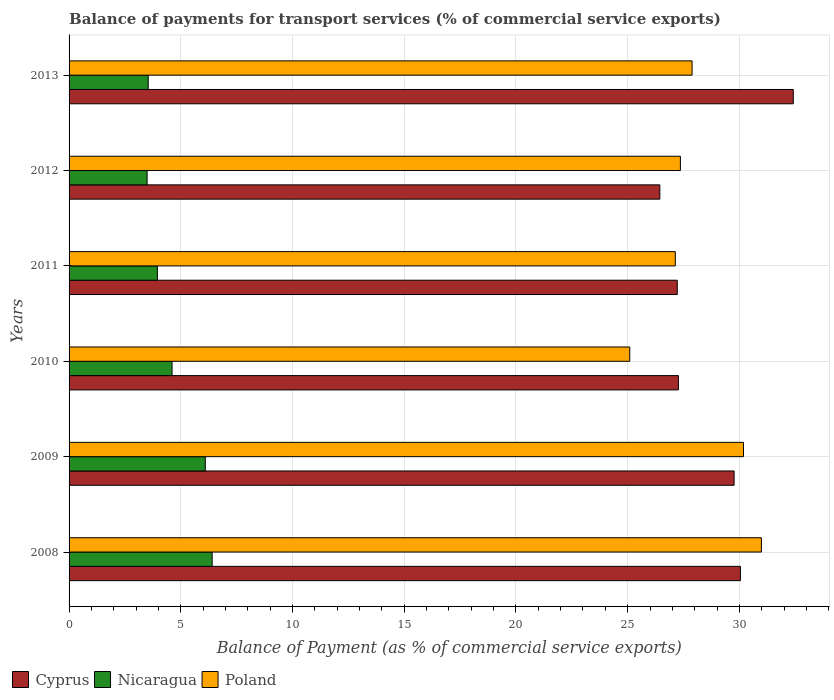Are the number of bars per tick equal to the number of legend labels?
Your answer should be very brief. Yes. How many bars are there on the 6th tick from the top?
Your response must be concise. 3. What is the label of the 3rd group of bars from the top?
Ensure brevity in your answer.  2011. In how many cases, is the number of bars for a given year not equal to the number of legend labels?
Your response must be concise. 0. What is the balance of payments for transport services in Poland in 2013?
Ensure brevity in your answer.  27.88. Across all years, what is the maximum balance of payments for transport services in Poland?
Give a very brief answer. 30.99. Across all years, what is the minimum balance of payments for transport services in Poland?
Your answer should be compact. 25.09. In which year was the balance of payments for transport services in Nicaragua minimum?
Your answer should be very brief. 2012. What is the total balance of payments for transport services in Poland in the graph?
Make the answer very short. 168.64. What is the difference between the balance of payments for transport services in Cyprus in 2009 and that in 2013?
Provide a succinct answer. -2.65. What is the difference between the balance of payments for transport services in Poland in 2008 and the balance of payments for transport services in Cyprus in 2012?
Your answer should be compact. 4.55. What is the average balance of payments for transport services in Poland per year?
Keep it short and to the point. 28.11. In the year 2010, what is the difference between the balance of payments for transport services in Poland and balance of payments for transport services in Nicaragua?
Make the answer very short. 20.48. In how many years, is the balance of payments for transport services in Cyprus greater than 9 %?
Keep it short and to the point. 6. What is the ratio of the balance of payments for transport services in Cyprus in 2008 to that in 2010?
Keep it short and to the point. 1.1. Is the balance of payments for transport services in Nicaragua in 2011 less than that in 2012?
Keep it short and to the point. No. Is the difference between the balance of payments for transport services in Poland in 2009 and 2013 greater than the difference between the balance of payments for transport services in Nicaragua in 2009 and 2013?
Provide a succinct answer. No. What is the difference between the highest and the second highest balance of payments for transport services in Nicaragua?
Offer a terse response. 0.31. What is the difference between the highest and the lowest balance of payments for transport services in Nicaragua?
Your answer should be very brief. 2.91. Is the sum of the balance of payments for transport services in Nicaragua in 2009 and 2011 greater than the maximum balance of payments for transport services in Poland across all years?
Provide a short and direct response. No. What does the 1st bar from the bottom in 2008 represents?
Your answer should be very brief. Cyprus. Is it the case that in every year, the sum of the balance of payments for transport services in Nicaragua and balance of payments for transport services in Cyprus is greater than the balance of payments for transport services in Poland?
Make the answer very short. Yes. Are all the bars in the graph horizontal?
Your answer should be compact. Yes. Are the values on the major ticks of X-axis written in scientific E-notation?
Provide a short and direct response. No. Where does the legend appear in the graph?
Offer a very short reply. Bottom left. How many legend labels are there?
Offer a terse response. 3. How are the legend labels stacked?
Your answer should be very brief. Horizontal. What is the title of the graph?
Your answer should be very brief. Balance of payments for transport services (% of commercial service exports). What is the label or title of the X-axis?
Provide a short and direct response. Balance of Payment (as % of commercial service exports). What is the label or title of the Y-axis?
Your response must be concise. Years. What is the Balance of Payment (as % of commercial service exports) of Cyprus in 2008?
Your answer should be very brief. 30.05. What is the Balance of Payment (as % of commercial service exports) of Nicaragua in 2008?
Make the answer very short. 6.4. What is the Balance of Payment (as % of commercial service exports) of Poland in 2008?
Your answer should be very brief. 30.99. What is the Balance of Payment (as % of commercial service exports) in Cyprus in 2009?
Your answer should be compact. 29.76. What is the Balance of Payment (as % of commercial service exports) in Nicaragua in 2009?
Keep it short and to the point. 6.1. What is the Balance of Payment (as % of commercial service exports) of Poland in 2009?
Offer a terse response. 30.18. What is the Balance of Payment (as % of commercial service exports) in Cyprus in 2010?
Keep it short and to the point. 27.27. What is the Balance of Payment (as % of commercial service exports) in Nicaragua in 2010?
Keep it short and to the point. 4.61. What is the Balance of Payment (as % of commercial service exports) of Poland in 2010?
Provide a short and direct response. 25.09. What is the Balance of Payment (as % of commercial service exports) of Cyprus in 2011?
Your response must be concise. 27.22. What is the Balance of Payment (as % of commercial service exports) in Nicaragua in 2011?
Ensure brevity in your answer.  3.95. What is the Balance of Payment (as % of commercial service exports) of Poland in 2011?
Your response must be concise. 27.13. What is the Balance of Payment (as % of commercial service exports) of Cyprus in 2012?
Offer a terse response. 26.44. What is the Balance of Payment (as % of commercial service exports) in Nicaragua in 2012?
Give a very brief answer. 3.49. What is the Balance of Payment (as % of commercial service exports) of Poland in 2012?
Ensure brevity in your answer.  27.36. What is the Balance of Payment (as % of commercial service exports) in Cyprus in 2013?
Your answer should be very brief. 32.41. What is the Balance of Payment (as % of commercial service exports) of Nicaragua in 2013?
Offer a very short reply. 3.54. What is the Balance of Payment (as % of commercial service exports) of Poland in 2013?
Keep it short and to the point. 27.88. Across all years, what is the maximum Balance of Payment (as % of commercial service exports) in Cyprus?
Make the answer very short. 32.41. Across all years, what is the maximum Balance of Payment (as % of commercial service exports) of Nicaragua?
Offer a terse response. 6.4. Across all years, what is the maximum Balance of Payment (as % of commercial service exports) in Poland?
Give a very brief answer. 30.99. Across all years, what is the minimum Balance of Payment (as % of commercial service exports) of Cyprus?
Offer a very short reply. 26.44. Across all years, what is the minimum Balance of Payment (as % of commercial service exports) in Nicaragua?
Give a very brief answer. 3.49. Across all years, what is the minimum Balance of Payment (as % of commercial service exports) in Poland?
Ensure brevity in your answer.  25.09. What is the total Balance of Payment (as % of commercial service exports) of Cyprus in the graph?
Your answer should be very brief. 173.15. What is the total Balance of Payment (as % of commercial service exports) in Nicaragua in the graph?
Give a very brief answer. 28.09. What is the total Balance of Payment (as % of commercial service exports) in Poland in the graph?
Give a very brief answer. 168.64. What is the difference between the Balance of Payment (as % of commercial service exports) in Cyprus in 2008 and that in 2009?
Give a very brief answer. 0.28. What is the difference between the Balance of Payment (as % of commercial service exports) in Nicaragua in 2008 and that in 2009?
Your answer should be very brief. 0.31. What is the difference between the Balance of Payment (as % of commercial service exports) in Poland in 2008 and that in 2009?
Your answer should be very brief. 0.8. What is the difference between the Balance of Payment (as % of commercial service exports) in Cyprus in 2008 and that in 2010?
Offer a terse response. 2.78. What is the difference between the Balance of Payment (as % of commercial service exports) of Nicaragua in 2008 and that in 2010?
Your response must be concise. 1.79. What is the difference between the Balance of Payment (as % of commercial service exports) in Poland in 2008 and that in 2010?
Provide a succinct answer. 5.89. What is the difference between the Balance of Payment (as % of commercial service exports) of Cyprus in 2008 and that in 2011?
Provide a succinct answer. 2.83. What is the difference between the Balance of Payment (as % of commercial service exports) of Nicaragua in 2008 and that in 2011?
Your answer should be compact. 2.45. What is the difference between the Balance of Payment (as % of commercial service exports) in Poland in 2008 and that in 2011?
Offer a terse response. 3.85. What is the difference between the Balance of Payment (as % of commercial service exports) in Cyprus in 2008 and that in 2012?
Your answer should be compact. 3.61. What is the difference between the Balance of Payment (as % of commercial service exports) in Nicaragua in 2008 and that in 2012?
Your answer should be compact. 2.91. What is the difference between the Balance of Payment (as % of commercial service exports) in Poland in 2008 and that in 2012?
Give a very brief answer. 3.63. What is the difference between the Balance of Payment (as % of commercial service exports) in Cyprus in 2008 and that in 2013?
Provide a short and direct response. -2.37. What is the difference between the Balance of Payment (as % of commercial service exports) of Nicaragua in 2008 and that in 2013?
Make the answer very short. 2.86. What is the difference between the Balance of Payment (as % of commercial service exports) of Poland in 2008 and that in 2013?
Provide a succinct answer. 3.1. What is the difference between the Balance of Payment (as % of commercial service exports) of Cyprus in 2009 and that in 2010?
Keep it short and to the point. 2.49. What is the difference between the Balance of Payment (as % of commercial service exports) in Nicaragua in 2009 and that in 2010?
Offer a terse response. 1.49. What is the difference between the Balance of Payment (as % of commercial service exports) of Poland in 2009 and that in 2010?
Give a very brief answer. 5.09. What is the difference between the Balance of Payment (as % of commercial service exports) of Cyprus in 2009 and that in 2011?
Your response must be concise. 2.54. What is the difference between the Balance of Payment (as % of commercial service exports) in Nicaragua in 2009 and that in 2011?
Provide a succinct answer. 2.14. What is the difference between the Balance of Payment (as % of commercial service exports) of Poland in 2009 and that in 2011?
Ensure brevity in your answer.  3.05. What is the difference between the Balance of Payment (as % of commercial service exports) of Cyprus in 2009 and that in 2012?
Give a very brief answer. 3.32. What is the difference between the Balance of Payment (as % of commercial service exports) in Nicaragua in 2009 and that in 2012?
Your answer should be very brief. 2.6. What is the difference between the Balance of Payment (as % of commercial service exports) of Poland in 2009 and that in 2012?
Your answer should be compact. 2.82. What is the difference between the Balance of Payment (as % of commercial service exports) of Cyprus in 2009 and that in 2013?
Offer a very short reply. -2.65. What is the difference between the Balance of Payment (as % of commercial service exports) in Nicaragua in 2009 and that in 2013?
Provide a succinct answer. 2.56. What is the difference between the Balance of Payment (as % of commercial service exports) of Poland in 2009 and that in 2013?
Offer a very short reply. 2.3. What is the difference between the Balance of Payment (as % of commercial service exports) of Cyprus in 2010 and that in 2011?
Provide a short and direct response. 0.05. What is the difference between the Balance of Payment (as % of commercial service exports) of Nicaragua in 2010 and that in 2011?
Provide a short and direct response. 0.66. What is the difference between the Balance of Payment (as % of commercial service exports) of Poland in 2010 and that in 2011?
Make the answer very short. -2.04. What is the difference between the Balance of Payment (as % of commercial service exports) in Cyprus in 2010 and that in 2012?
Offer a terse response. 0.83. What is the difference between the Balance of Payment (as % of commercial service exports) in Nicaragua in 2010 and that in 2012?
Provide a succinct answer. 1.12. What is the difference between the Balance of Payment (as % of commercial service exports) in Poland in 2010 and that in 2012?
Make the answer very short. -2.27. What is the difference between the Balance of Payment (as % of commercial service exports) of Cyprus in 2010 and that in 2013?
Provide a short and direct response. -5.14. What is the difference between the Balance of Payment (as % of commercial service exports) of Nicaragua in 2010 and that in 2013?
Your answer should be compact. 1.07. What is the difference between the Balance of Payment (as % of commercial service exports) in Poland in 2010 and that in 2013?
Offer a terse response. -2.79. What is the difference between the Balance of Payment (as % of commercial service exports) of Cyprus in 2011 and that in 2012?
Provide a short and direct response. 0.78. What is the difference between the Balance of Payment (as % of commercial service exports) of Nicaragua in 2011 and that in 2012?
Keep it short and to the point. 0.46. What is the difference between the Balance of Payment (as % of commercial service exports) in Poland in 2011 and that in 2012?
Give a very brief answer. -0.23. What is the difference between the Balance of Payment (as % of commercial service exports) in Cyprus in 2011 and that in 2013?
Give a very brief answer. -5.19. What is the difference between the Balance of Payment (as % of commercial service exports) of Nicaragua in 2011 and that in 2013?
Provide a short and direct response. 0.41. What is the difference between the Balance of Payment (as % of commercial service exports) of Poland in 2011 and that in 2013?
Keep it short and to the point. -0.75. What is the difference between the Balance of Payment (as % of commercial service exports) in Cyprus in 2012 and that in 2013?
Your answer should be very brief. -5.97. What is the difference between the Balance of Payment (as % of commercial service exports) in Nicaragua in 2012 and that in 2013?
Offer a terse response. -0.05. What is the difference between the Balance of Payment (as % of commercial service exports) in Poland in 2012 and that in 2013?
Make the answer very short. -0.52. What is the difference between the Balance of Payment (as % of commercial service exports) of Cyprus in 2008 and the Balance of Payment (as % of commercial service exports) of Nicaragua in 2009?
Your answer should be compact. 23.95. What is the difference between the Balance of Payment (as % of commercial service exports) of Cyprus in 2008 and the Balance of Payment (as % of commercial service exports) of Poland in 2009?
Keep it short and to the point. -0.14. What is the difference between the Balance of Payment (as % of commercial service exports) of Nicaragua in 2008 and the Balance of Payment (as % of commercial service exports) of Poland in 2009?
Offer a very short reply. -23.78. What is the difference between the Balance of Payment (as % of commercial service exports) in Cyprus in 2008 and the Balance of Payment (as % of commercial service exports) in Nicaragua in 2010?
Give a very brief answer. 25.44. What is the difference between the Balance of Payment (as % of commercial service exports) in Cyprus in 2008 and the Balance of Payment (as % of commercial service exports) in Poland in 2010?
Provide a succinct answer. 4.95. What is the difference between the Balance of Payment (as % of commercial service exports) of Nicaragua in 2008 and the Balance of Payment (as % of commercial service exports) of Poland in 2010?
Your answer should be very brief. -18.69. What is the difference between the Balance of Payment (as % of commercial service exports) in Cyprus in 2008 and the Balance of Payment (as % of commercial service exports) in Nicaragua in 2011?
Your answer should be compact. 26.09. What is the difference between the Balance of Payment (as % of commercial service exports) in Cyprus in 2008 and the Balance of Payment (as % of commercial service exports) in Poland in 2011?
Offer a terse response. 2.91. What is the difference between the Balance of Payment (as % of commercial service exports) of Nicaragua in 2008 and the Balance of Payment (as % of commercial service exports) of Poland in 2011?
Your answer should be very brief. -20.73. What is the difference between the Balance of Payment (as % of commercial service exports) of Cyprus in 2008 and the Balance of Payment (as % of commercial service exports) of Nicaragua in 2012?
Your answer should be very brief. 26.55. What is the difference between the Balance of Payment (as % of commercial service exports) of Cyprus in 2008 and the Balance of Payment (as % of commercial service exports) of Poland in 2012?
Make the answer very short. 2.69. What is the difference between the Balance of Payment (as % of commercial service exports) in Nicaragua in 2008 and the Balance of Payment (as % of commercial service exports) in Poland in 2012?
Give a very brief answer. -20.96. What is the difference between the Balance of Payment (as % of commercial service exports) in Cyprus in 2008 and the Balance of Payment (as % of commercial service exports) in Nicaragua in 2013?
Your response must be concise. 26.5. What is the difference between the Balance of Payment (as % of commercial service exports) of Cyprus in 2008 and the Balance of Payment (as % of commercial service exports) of Poland in 2013?
Your answer should be very brief. 2.16. What is the difference between the Balance of Payment (as % of commercial service exports) of Nicaragua in 2008 and the Balance of Payment (as % of commercial service exports) of Poland in 2013?
Keep it short and to the point. -21.48. What is the difference between the Balance of Payment (as % of commercial service exports) of Cyprus in 2009 and the Balance of Payment (as % of commercial service exports) of Nicaragua in 2010?
Provide a succinct answer. 25.15. What is the difference between the Balance of Payment (as % of commercial service exports) of Cyprus in 2009 and the Balance of Payment (as % of commercial service exports) of Poland in 2010?
Your response must be concise. 4.67. What is the difference between the Balance of Payment (as % of commercial service exports) of Nicaragua in 2009 and the Balance of Payment (as % of commercial service exports) of Poland in 2010?
Provide a short and direct response. -19. What is the difference between the Balance of Payment (as % of commercial service exports) in Cyprus in 2009 and the Balance of Payment (as % of commercial service exports) in Nicaragua in 2011?
Your answer should be very brief. 25.81. What is the difference between the Balance of Payment (as % of commercial service exports) in Cyprus in 2009 and the Balance of Payment (as % of commercial service exports) in Poland in 2011?
Your response must be concise. 2.63. What is the difference between the Balance of Payment (as % of commercial service exports) in Nicaragua in 2009 and the Balance of Payment (as % of commercial service exports) in Poland in 2011?
Keep it short and to the point. -21.04. What is the difference between the Balance of Payment (as % of commercial service exports) of Cyprus in 2009 and the Balance of Payment (as % of commercial service exports) of Nicaragua in 2012?
Provide a short and direct response. 26.27. What is the difference between the Balance of Payment (as % of commercial service exports) of Cyprus in 2009 and the Balance of Payment (as % of commercial service exports) of Poland in 2012?
Your response must be concise. 2.4. What is the difference between the Balance of Payment (as % of commercial service exports) of Nicaragua in 2009 and the Balance of Payment (as % of commercial service exports) of Poland in 2012?
Ensure brevity in your answer.  -21.26. What is the difference between the Balance of Payment (as % of commercial service exports) in Cyprus in 2009 and the Balance of Payment (as % of commercial service exports) in Nicaragua in 2013?
Keep it short and to the point. 26.22. What is the difference between the Balance of Payment (as % of commercial service exports) of Cyprus in 2009 and the Balance of Payment (as % of commercial service exports) of Poland in 2013?
Your answer should be very brief. 1.88. What is the difference between the Balance of Payment (as % of commercial service exports) in Nicaragua in 2009 and the Balance of Payment (as % of commercial service exports) in Poland in 2013?
Provide a succinct answer. -21.79. What is the difference between the Balance of Payment (as % of commercial service exports) of Cyprus in 2010 and the Balance of Payment (as % of commercial service exports) of Nicaragua in 2011?
Offer a terse response. 23.32. What is the difference between the Balance of Payment (as % of commercial service exports) of Cyprus in 2010 and the Balance of Payment (as % of commercial service exports) of Poland in 2011?
Ensure brevity in your answer.  0.14. What is the difference between the Balance of Payment (as % of commercial service exports) in Nicaragua in 2010 and the Balance of Payment (as % of commercial service exports) in Poland in 2011?
Ensure brevity in your answer.  -22.52. What is the difference between the Balance of Payment (as % of commercial service exports) of Cyprus in 2010 and the Balance of Payment (as % of commercial service exports) of Nicaragua in 2012?
Provide a succinct answer. 23.78. What is the difference between the Balance of Payment (as % of commercial service exports) in Cyprus in 2010 and the Balance of Payment (as % of commercial service exports) in Poland in 2012?
Ensure brevity in your answer.  -0.09. What is the difference between the Balance of Payment (as % of commercial service exports) of Nicaragua in 2010 and the Balance of Payment (as % of commercial service exports) of Poland in 2012?
Provide a succinct answer. -22.75. What is the difference between the Balance of Payment (as % of commercial service exports) of Cyprus in 2010 and the Balance of Payment (as % of commercial service exports) of Nicaragua in 2013?
Provide a succinct answer. 23.73. What is the difference between the Balance of Payment (as % of commercial service exports) of Cyprus in 2010 and the Balance of Payment (as % of commercial service exports) of Poland in 2013?
Give a very brief answer. -0.61. What is the difference between the Balance of Payment (as % of commercial service exports) in Nicaragua in 2010 and the Balance of Payment (as % of commercial service exports) in Poland in 2013?
Your answer should be compact. -23.27. What is the difference between the Balance of Payment (as % of commercial service exports) in Cyprus in 2011 and the Balance of Payment (as % of commercial service exports) in Nicaragua in 2012?
Give a very brief answer. 23.73. What is the difference between the Balance of Payment (as % of commercial service exports) in Cyprus in 2011 and the Balance of Payment (as % of commercial service exports) in Poland in 2012?
Give a very brief answer. -0.14. What is the difference between the Balance of Payment (as % of commercial service exports) in Nicaragua in 2011 and the Balance of Payment (as % of commercial service exports) in Poland in 2012?
Offer a very short reply. -23.41. What is the difference between the Balance of Payment (as % of commercial service exports) in Cyprus in 2011 and the Balance of Payment (as % of commercial service exports) in Nicaragua in 2013?
Your answer should be compact. 23.68. What is the difference between the Balance of Payment (as % of commercial service exports) in Cyprus in 2011 and the Balance of Payment (as % of commercial service exports) in Poland in 2013?
Ensure brevity in your answer.  -0.66. What is the difference between the Balance of Payment (as % of commercial service exports) in Nicaragua in 2011 and the Balance of Payment (as % of commercial service exports) in Poland in 2013?
Provide a succinct answer. -23.93. What is the difference between the Balance of Payment (as % of commercial service exports) of Cyprus in 2012 and the Balance of Payment (as % of commercial service exports) of Nicaragua in 2013?
Offer a terse response. 22.9. What is the difference between the Balance of Payment (as % of commercial service exports) of Cyprus in 2012 and the Balance of Payment (as % of commercial service exports) of Poland in 2013?
Give a very brief answer. -1.44. What is the difference between the Balance of Payment (as % of commercial service exports) in Nicaragua in 2012 and the Balance of Payment (as % of commercial service exports) in Poland in 2013?
Provide a short and direct response. -24.39. What is the average Balance of Payment (as % of commercial service exports) of Cyprus per year?
Provide a succinct answer. 28.86. What is the average Balance of Payment (as % of commercial service exports) of Nicaragua per year?
Provide a succinct answer. 4.68. What is the average Balance of Payment (as % of commercial service exports) of Poland per year?
Make the answer very short. 28.11. In the year 2008, what is the difference between the Balance of Payment (as % of commercial service exports) in Cyprus and Balance of Payment (as % of commercial service exports) in Nicaragua?
Ensure brevity in your answer.  23.64. In the year 2008, what is the difference between the Balance of Payment (as % of commercial service exports) of Cyprus and Balance of Payment (as % of commercial service exports) of Poland?
Give a very brief answer. -0.94. In the year 2008, what is the difference between the Balance of Payment (as % of commercial service exports) in Nicaragua and Balance of Payment (as % of commercial service exports) in Poland?
Offer a very short reply. -24.58. In the year 2009, what is the difference between the Balance of Payment (as % of commercial service exports) of Cyprus and Balance of Payment (as % of commercial service exports) of Nicaragua?
Offer a terse response. 23.67. In the year 2009, what is the difference between the Balance of Payment (as % of commercial service exports) in Cyprus and Balance of Payment (as % of commercial service exports) in Poland?
Provide a short and direct response. -0.42. In the year 2009, what is the difference between the Balance of Payment (as % of commercial service exports) in Nicaragua and Balance of Payment (as % of commercial service exports) in Poland?
Your answer should be very brief. -24.09. In the year 2010, what is the difference between the Balance of Payment (as % of commercial service exports) in Cyprus and Balance of Payment (as % of commercial service exports) in Nicaragua?
Give a very brief answer. 22.66. In the year 2010, what is the difference between the Balance of Payment (as % of commercial service exports) in Cyprus and Balance of Payment (as % of commercial service exports) in Poland?
Provide a succinct answer. 2.18. In the year 2010, what is the difference between the Balance of Payment (as % of commercial service exports) of Nicaragua and Balance of Payment (as % of commercial service exports) of Poland?
Keep it short and to the point. -20.48. In the year 2011, what is the difference between the Balance of Payment (as % of commercial service exports) in Cyprus and Balance of Payment (as % of commercial service exports) in Nicaragua?
Your answer should be compact. 23.27. In the year 2011, what is the difference between the Balance of Payment (as % of commercial service exports) in Cyprus and Balance of Payment (as % of commercial service exports) in Poland?
Your answer should be compact. 0.09. In the year 2011, what is the difference between the Balance of Payment (as % of commercial service exports) of Nicaragua and Balance of Payment (as % of commercial service exports) of Poland?
Make the answer very short. -23.18. In the year 2012, what is the difference between the Balance of Payment (as % of commercial service exports) in Cyprus and Balance of Payment (as % of commercial service exports) in Nicaragua?
Your response must be concise. 22.95. In the year 2012, what is the difference between the Balance of Payment (as % of commercial service exports) of Cyprus and Balance of Payment (as % of commercial service exports) of Poland?
Provide a succinct answer. -0.92. In the year 2012, what is the difference between the Balance of Payment (as % of commercial service exports) of Nicaragua and Balance of Payment (as % of commercial service exports) of Poland?
Offer a very short reply. -23.87. In the year 2013, what is the difference between the Balance of Payment (as % of commercial service exports) in Cyprus and Balance of Payment (as % of commercial service exports) in Nicaragua?
Your answer should be compact. 28.87. In the year 2013, what is the difference between the Balance of Payment (as % of commercial service exports) of Cyprus and Balance of Payment (as % of commercial service exports) of Poland?
Offer a terse response. 4.53. In the year 2013, what is the difference between the Balance of Payment (as % of commercial service exports) of Nicaragua and Balance of Payment (as % of commercial service exports) of Poland?
Your response must be concise. -24.34. What is the ratio of the Balance of Payment (as % of commercial service exports) in Cyprus in 2008 to that in 2009?
Ensure brevity in your answer.  1.01. What is the ratio of the Balance of Payment (as % of commercial service exports) of Nicaragua in 2008 to that in 2009?
Keep it short and to the point. 1.05. What is the ratio of the Balance of Payment (as % of commercial service exports) in Poland in 2008 to that in 2009?
Make the answer very short. 1.03. What is the ratio of the Balance of Payment (as % of commercial service exports) of Cyprus in 2008 to that in 2010?
Offer a very short reply. 1.1. What is the ratio of the Balance of Payment (as % of commercial service exports) in Nicaragua in 2008 to that in 2010?
Provide a succinct answer. 1.39. What is the ratio of the Balance of Payment (as % of commercial service exports) in Poland in 2008 to that in 2010?
Make the answer very short. 1.23. What is the ratio of the Balance of Payment (as % of commercial service exports) of Cyprus in 2008 to that in 2011?
Your answer should be very brief. 1.1. What is the ratio of the Balance of Payment (as % of commercial service exports) of Nicaragua in 2008 to that in 2011?
Offer a very short reply. 1.62. What is the ratio of the Balance of Payment (as % of commercial service exports) in Poland in 2008 to that in 2011?
Keep it short and to the point. 1.14. What is the ratio of the Balance of Payment (as % of commercial service exports) in Cyprus in 2008 to that in 2012?
Make the answer very short. 1.14. What is the ratio of the Balance of Payment (as % of commercial service exports) of Nicaragua in 2008 to that in 2012?
Keep it short and to the point. 1.83. What is the ratio of the Balance of Payment (as % of commercial service exports) of Poland in 2008 to that in 2012?
Provide a succinct answer. 1.13. What is the ratio of the Balance of Payment (as % of commercial service exports) in Cyprus in 2008 to that in 2013?
Your response must be concise. 0.93. What is the ratio of the Balance of Payment (as % of commercial service exports) in Nicaragua in 2008 to that in 2013?
Ensure brevity in your answer.  1.81. What is the ratio of the Balance of Payment (as % of commercial service exports) in Poland in 2008 to that in 2013?
Make the answer very short. 1.11. What is the ratio of the Balance of Payment (as % of commercial service exports) in Cyprus in 2009 to that in 2010?
Provide a short and direct response. 1.09. What is the ratio of the Balance of Payment (as % of commercial service exports) of Nicaragua in 2009 to that in 2010?
Your answer should be very brief. 1.32. What is the ratio of the Balance of Payment (as % of commercial service exports) of Poland in 2009 to that in 2010?
Offer a very short reply. 1.2. What is the ratio of the Balance of Payment (as % of commercial service exports) in Cyprus in 2009 to that in 2011?
Your answer should be compact. 1.09. What is the ratio of the Balance of Payment (as % of commercial service exports) in Nicaragua in 2009 to that in 2011?
Give a very brief answer. 1.54. What is the ratio of the Balance of Payment (as % of commercial service exports) in Poland in 2009 to that in 2011?
Offer a terse response. 1.11. What is the ratio of the Balance of Payment (as % of commercial service exports) in Cyprus in 2009 to that in 2012?
Provide a short and direct response. 1.13. What is the ratio of the Balance of Payment (as % of commercial service exports) of Nicaragua in 2009 to that in 2012?
Provide a short and direct response. 1.75. What is the ratio of the Balance of Payment (as % of commercial service exports) in Poland in 2009 to that in 2012?
Your answer should be compact. 1.1. What is the ratio of the Balance of Payment (as % of commercial service exports) in Cyprus in 2009 to that in 2013?
Your response must be concise. 0.92. What is the ratio of the Balance of Payment (as % of commercial service exports) of Nicaragua in 2009 to that in 2013?
Your answer should be compact. 1.72. What is the ratio of the Balance of Payment (as % of commercial service exports) in Poland in 2009 to that in 2013?
Your answer should be very brief. 1.08. What is the ratio of the Balance of Payment (as % of commercial service exports) in Nicaragua in 2010 to that in 2011?
Make the answer very short. 1.17. What is the ratio of the Balance of Payment (as % of commercial service exports) of Poland in 2010 to that in 2011?
Offer a very short reply. 0.92. What is the ratio of the Balance of Payment (as % of commercial service exports) of Cyprus in 2010 to that in 2012?
Ensure brevity in your answer.  1.03. What is the ratio of the Balance of Payment (as % of commercial service exports) in Nicaragua in 2010 to that in 2012?
Give a very brief answer. 1.32. What is the ratio of the Balance of Payment (as % of commercial service exports) in Poland in 2010 to that in 2012?
Ensure brevity in your answer.  0.92. What is the ratio of the Balance of Payment (as % of commercial service exports) of Cyprus in 2010 to that in 2013?
Your answer should be compact. 0.84. What is the ratio of the Balance of Payment (as % of commercial service exports) in Nicaragua in 2010 to that in 2013?
Provide a short and direct response. 1.3. What is the ratio of the Balance of Payment (as % of commercial service exports) of Poland in 2010 to that in 2013?
Your answer should be compact. 0.9. What is the ratio of the Balance of Payment (as % of commercial service exports) in Cyprus in 2011 to that in 2012?
Make the answer very short. 1.03. What is the ratio of the Balance of Payment (as % of commercial service exports) in Nicaragua in 2011 to that in 2012?
Your answer should be compact. 1.13. What is the ratio of the Balance of Payment (as % of commercial service exports) of Poland in 2011 to that in 2012?
Provide a short and direct response. 0.99. What is the ratio of the Balance of Payment (as % of commercial service exports) in Cyprus in 2011 to that in 2013?
Offer a very short reply. 0.84. What is the ratio of the Balance of Payment (as % of commercial service exports) in Nicaragua in 2011 to that in 2013?
Provide a short and direct response. 1.12. What is the ratio of the Balance of Payment (as % of commercial service exports) of Poland in 2011 to that in 2013?
Make the answer very short. 0.97. What is the ratio of the Balance of Payment (as % of commercial service exports) of Cyprus in 2012 to that in 2013?
Your answer should be compact. 0.82. What is the ratio of the Balance of Payment (as % of commercial service exports) in Nicaragua in 2012 to that in 2013?
Your answer should be very brief. 0.99. What is the ratio of the Balance of Payment (as % of commercial service exports) in Poland in 2012 to that in 2013?
Offer a very short reply. 0.98. What is the difference between the highest and the second highest Balance of Payment (as % of commercial service exports) of Cyprus?
Offer a terse response. 2.37. What is the difference between the highest and the second highest Balance of Payment (as % of commercial service exports) in Nicaragua?
Provide a succinct answer. 0.31. What is the difference between the highest and the second highest Balance of Payment (as % of commercial service exports) of Poland?
Give a very brief answer. 0.8. What is the difference between the highest and the lowest Balance of Payment (as % of commercial service exports) in Cyprus?
Offer a very short reply. 5.97. What is the difference between the highest and the lowest Balance of Payment (as % of commercial service exports) in Nicaragua?
Ensure brevity in your answer.  2.91. What is the difference between the highest and the lowest Balance of Payment (as % of commercial service exports) in Poland?
Provide a short and direct response. 5.89. 